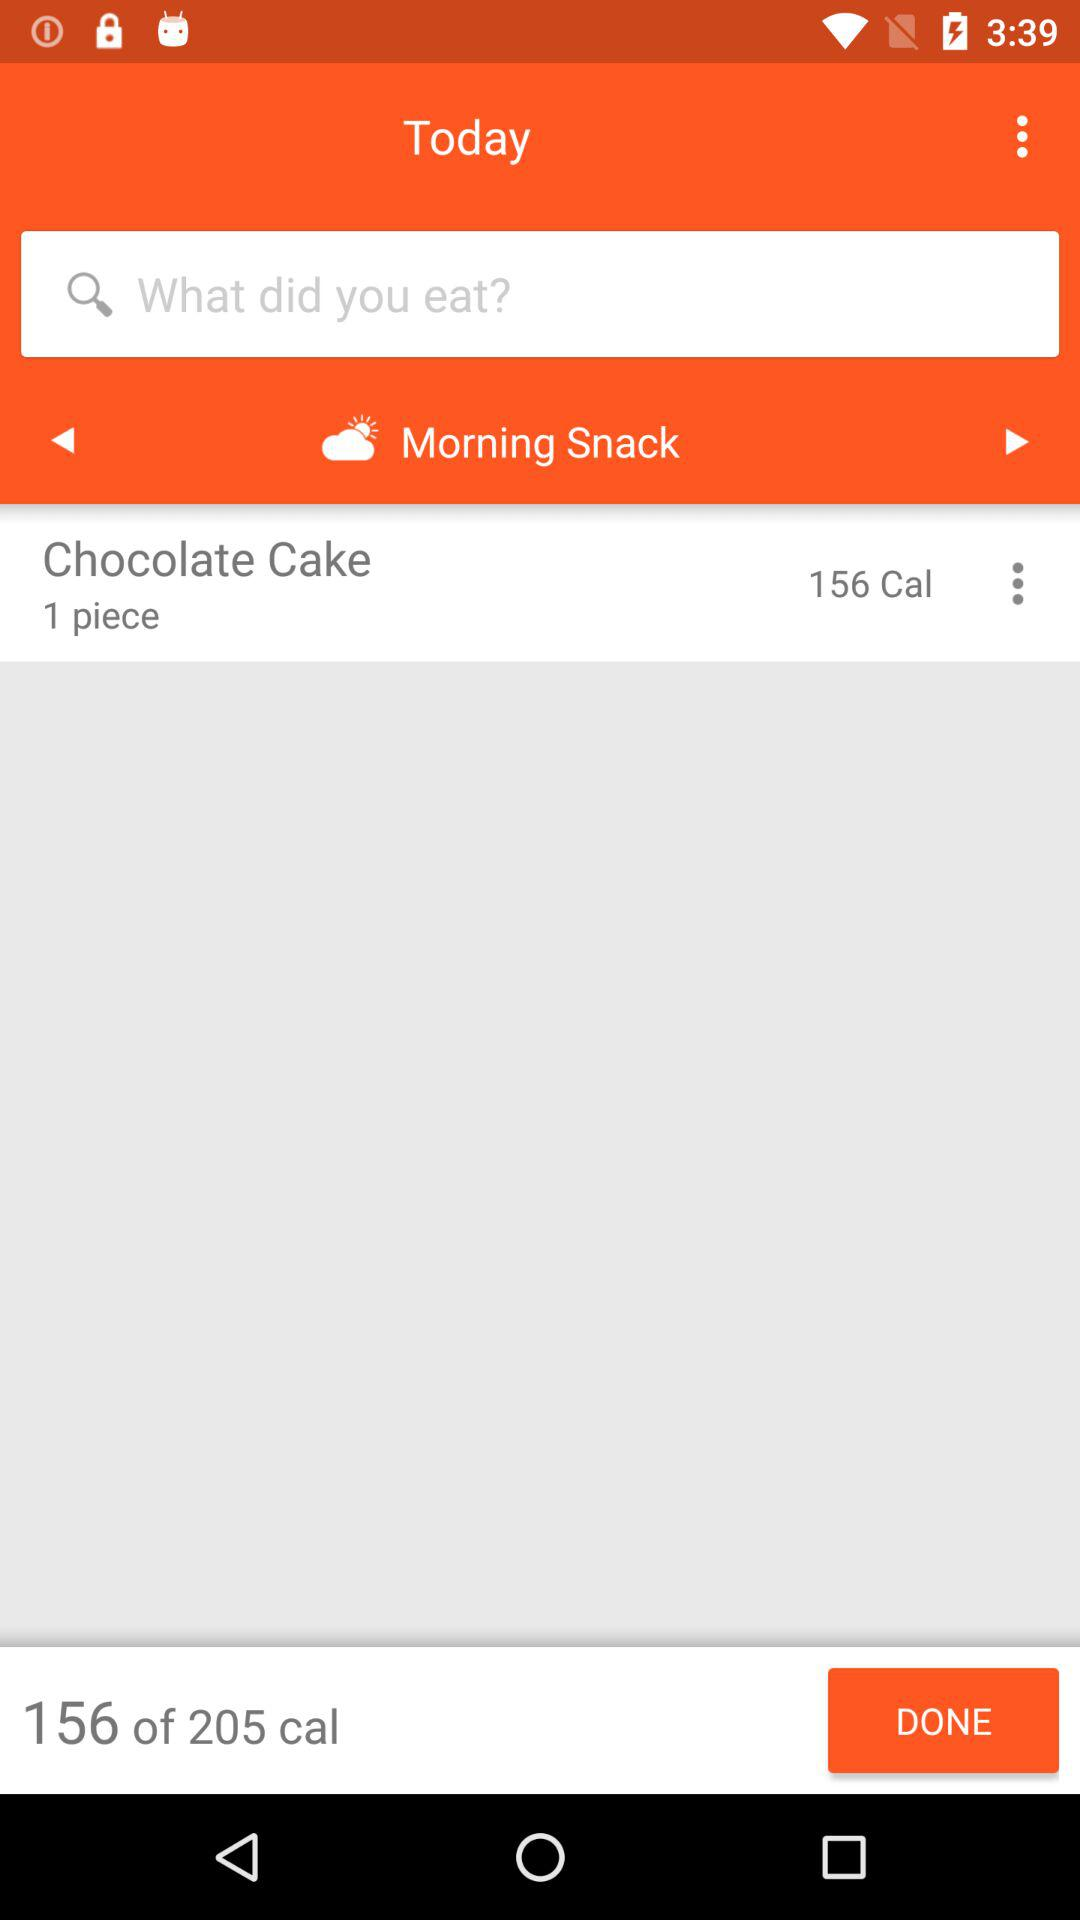What is in the morning snack? There is "Chocolate Cake" in the morning snack. 